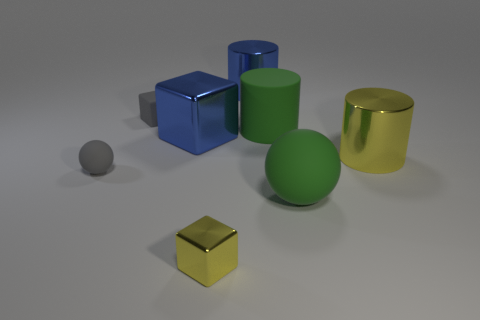Does the big matte sphere have the same color as the rubber cylinder?
Ensure brevity in your answer.  Yes. Is the material of the yellow thing that is right of the tiny yellow metallic cube the same as the small gray object that is in front of the gray matte cube?
Your response must be concise. No. How many small matte things are the same color as the tiny shiny object?
Your response must be concise. 0. The yellow object in front of the rubber thing that is left of the gray matte thing that is behind the big blue metallic block is what shape?
Make the answer very short. Cube. What size is the cube that is the same material as the tiny gray ball?
Your answer should be very brief. Small. Are there more yellow blocks than large metal cylinders?
Make the answer very short. No. What material is the green cylinder that is the same size as the yellow cylinder?
Your answer should be compact. Rubber. There is a rubber sphere to the right of the gray sphere; does it have the same size as the large yellow shiny object?
Make the answer very short. Yes. What number of balls are either small rubber things or big matte things?
Make the answer very short. 2. There is a yellow thing that is in front of the big yellow metallic cylinder; what material is it?
Offer a terse response. Metal. 